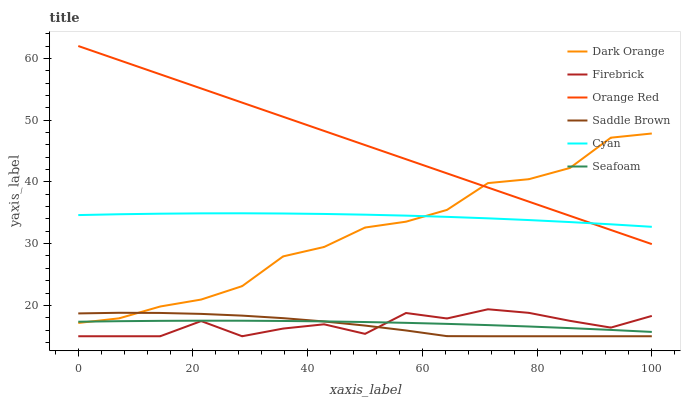Does Firebrick have the minimum area under the curve?
Answer yes or no. No. Does Firebrick have the maximum area under the curve?
Answer yes or no. No. Is Seafoam the smoothest?
Answer yes or no. No. Is Seafoam the roughest?
Answer yes or no. No. Does Seafoam have the lowest value?
Answer yes or no. No. Does Firebrick have the highest value?
Answer yes or no. No. Is Firebrick less than Orange Red?
Answer yes or no. Yes. Is Cyan greater than Firebrick?
Answer yes or no. Yes. Does Firebrick intersect Orange Red?
Answer yes or no. No. 